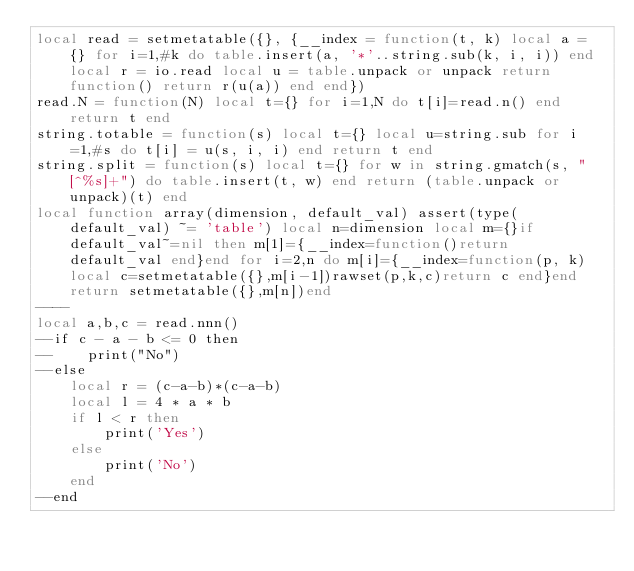Convert code to text. <code><loc_0><loc_0><loc_500><loc_500><_Lua_>local read = setmetatable({}, {__index = function(t, k) local a = {} for i=1,#k do table.insert(a, '*'..string.sub(k, i, i)) end local r = io.read local u = table.unpack or unpack return function() return r(u(a)) end end})
read.N = function(N) local t={} for i=1,N do t[i]=read.n() end return t end
string.totable = function(s) local t={} local u=string.sub for i=1,#s do t[i] = u(s, i, i) end return t end
string.split = function(s) local t={} for w in string.gmatch(s, "[^%s]+") do table.insert(t, w) end return (table.unpack or unpack)(t) end
local function array(dimension, default_val) assert(type(default_val) ~= 'table') local n=dimension local m={}if default_val~=nil then m[1]={__index=function()return default_val end}end for i=2,n do m[i]={__index=function(p, k)local c=setmetatable({},m[i-1])rawset(p,k,c)return c end}end return setmetatable({},m[n])end
----
local a,b,c = read.nnn()
--if c - a - b <= 0 then
--    print("No")
--else
    local r = (c-a-b)*(c-a-b)
    local l = 4 * a * b
    if l < r then
        print('Yes')
    else
        print('No')
    end
--end</code> 